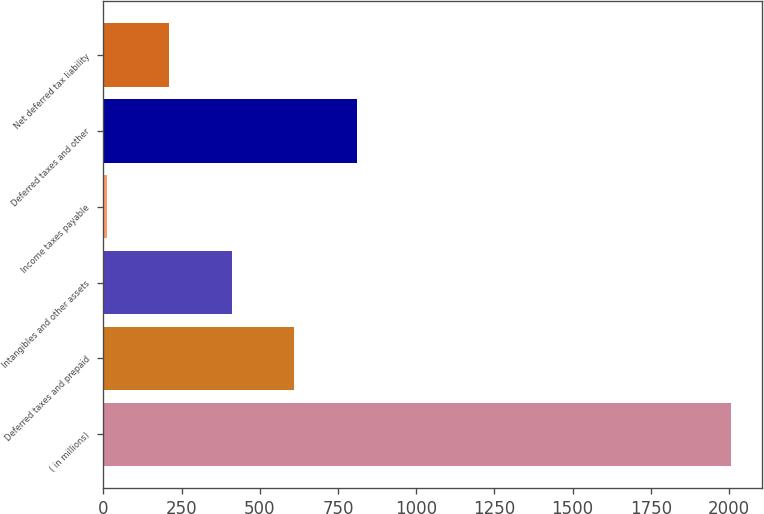Convert chart to OTSL. <chart><loc_0><loc_0><loc_500><loc_500><bar_chart><fcel>( in millions)<fcel>Deferred taxes and prepaid<fcel>Intangibles and other assets<fcel>Income taxes payable<fcel>Deferred taxes and other<fcel>Net deferred tax liability<nl><fcel>2006<fcel>609.78<fcel>410.32<fcel>11.4<fcel>809.24<fcel>210.86<nl></chart> 